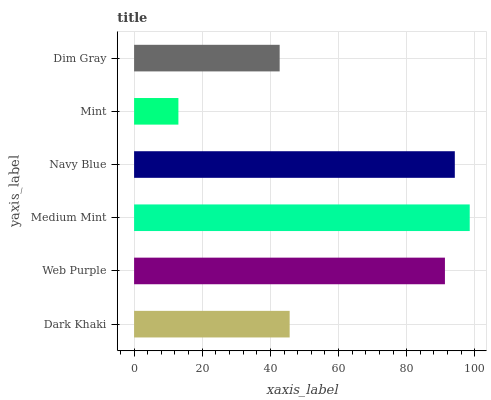Is Mint the minimum?
Answer yes or no. Yes. Is Medium Mint the maximum?
Answer yes or no. Yes. Is Web Purple the minimum?
Answer yes or no. No. Is Web Purple the maximum?
Answer yes or no. No. Is Web Purple greater than Dark Khaki?
Answer yes or no. Yes. Is Dark Khaki less than Web Purple?
Answer yes or no. Yes. Is Dark Khaki greater than Web Purple?
Answer yes or no. No. Is Web Purple less than Dark Khaki?
Answer yes or no. No. Is Web Purple the high median?
Answer yes or no. Yes. Is Dark Khaki the low median?
Answer yes or no. Yes. Is Dim Gray the high median?
Answer yes or no. No. Is Dim Gray the low median?
Answer yes or no. No. 